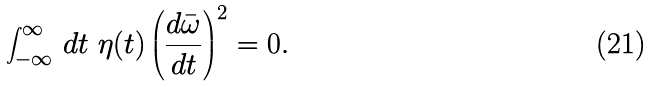<formula> <loc_0><loc_0><loc_500><loc_500>\int _ { - \infty } ^ { \infty } \, d t \ \eta ( t ) \left ( \frac { d \bar { \omega } } { d t } \right ) ^ { 2 } = 0 .</formula> 